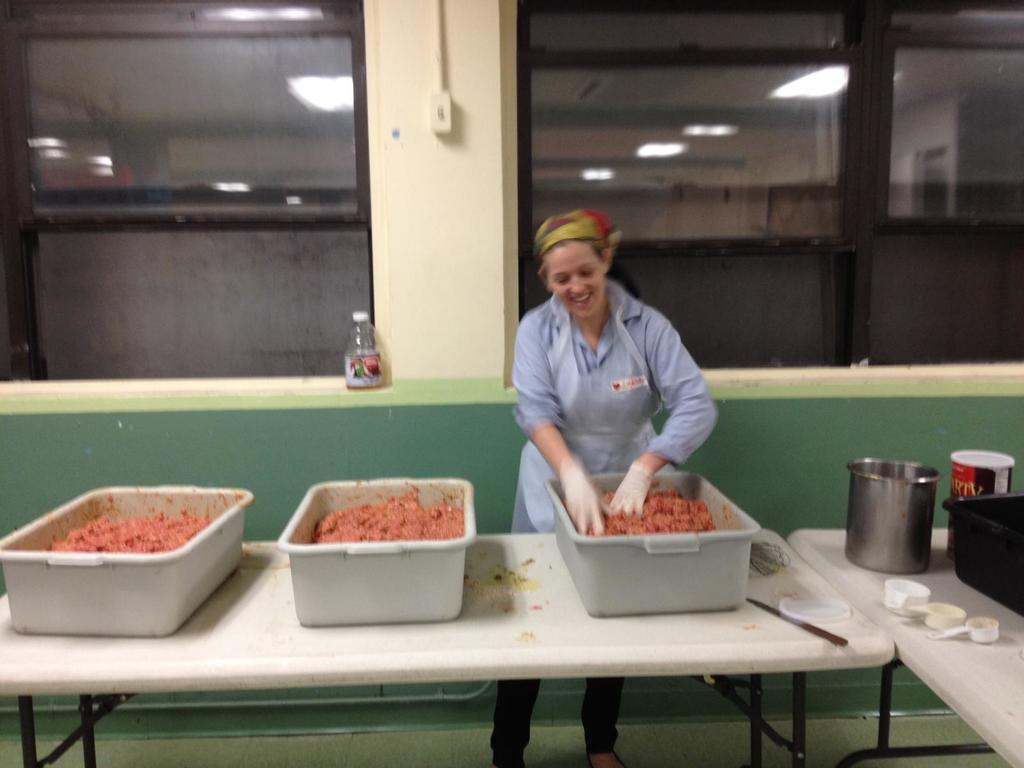Who is the main subject in the image? There is a woman in the image. Where is the woman positioned in the image? The woman is standing in the center of the image. What is the woman's facial expression in the image? The woman is smiling in the image. What is the woman doing with her hands in the image? The woman is mixing something in a tub with her hands. What type of nerve can be seen in the woman's hand in the image? There is no nerve visible in the woman's hand in the image. 